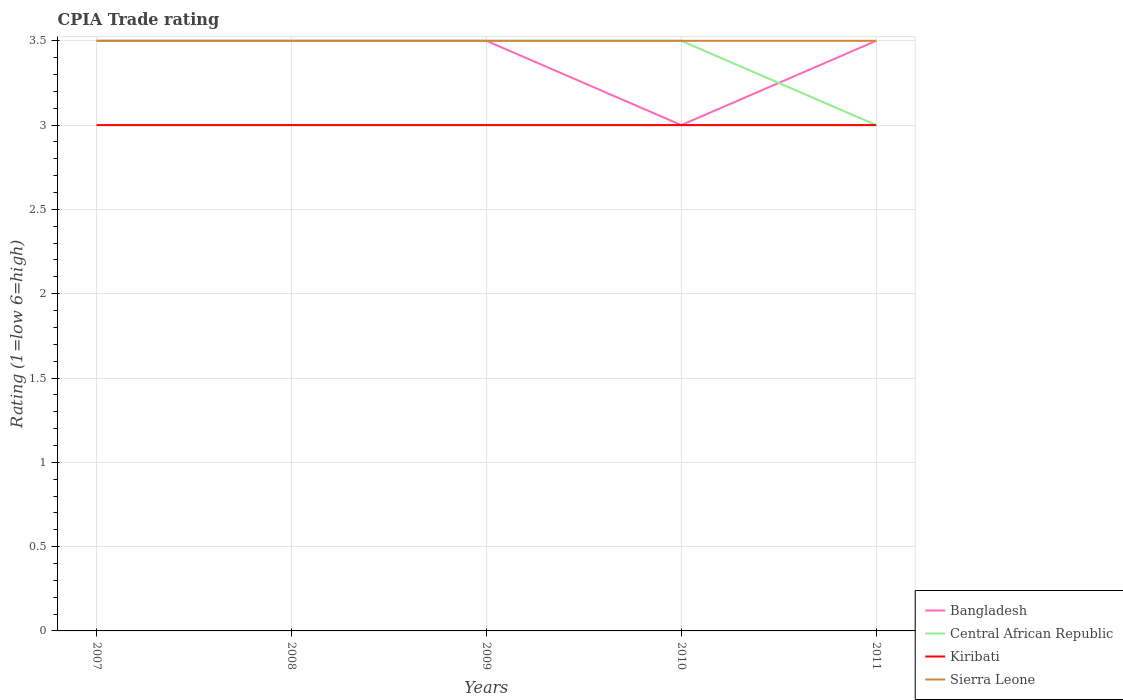How many different coloured lines are there?
Your response must be concise. 4. Across all years, what is the maximum CPIA rating in Bangladesh?
Ensure brevity in your answer.  3. In which year was the CPIA rating in Bangladesh maximum?
Ensure brevity in your answer.  2010. What is the difference between the highest and the lowest CPIA rating in Bangladesh?
Your response must be concise. 4. Is the CPIA rating in Bangladesh strictly greater than the CPIA rating in Sierra Leone over the years?
Ensure brevity in your answer.  No. Does the graph contain grids?
Give a very brief answer. Yes. What is the title of the graph?
Your response must be concise. CPIA Trade rating. What is the Rating (1=low 6=high) of Central African Republic in 2007?
Your answer should be compact. 3.5. What is the Rating (1=low 6=high) of Kiribati in 2007?
Provide a succinct answer. 3. What is the Rating (1=low 6=high) of Sierra Leone in 2007?
Offer a very short reply. 3.5. What is the Rating (1=low 6=high) in Bangladesh in 2008?
Offer a terse response. 3.5. What is the Rating (1=low 6=high) of Bangladesh in 2009?
Provide a succinct answer. 3.5. What is the Rating (1=low 6=high) in Central African Republic in 2009?
Your answer should be compact. 3.5. What is the Rating (1=low 6=high) in Central African Republic in 2010?
Your response must be concise. 3.5. What is the Rating (1=low 6=high) in Kiribati in 2010?
Give a very brief answer. 3. What is the Rating (1=low 6=high) in Sierra Leone in 2010?
Offer a very short reply. 3.5. What is the Rating (1=low 6=high) in Central African Republic in 2011?
Offer a terse response. 3. What is the Rating (1=low 6=high) in Kiribati in 2011?
Make the answer very short. 3. What is the Rating (1=low 6=high) of Sierra Leone in 2011?
Your response must be concise. 3.5. Across all years, what is the maximum Rating (1=low 6=high) in Kiribati?
Your response must be concise. 3. Across all years, what is the maximum Rating (1=low 6=high) in Sierra Leone?
Provide a succinct answer. 3.5. Across all years, what is the minimum Rating (1=low 6=high) in Bangladesh?
Make the answer very short. 3. Across all years, what is the minimum Rating (1=low 6=high) of Central African Republic?
Offer a terse response. 3. What is the total Rating (1=low 6=high) in Bangladesh in the graph?
Provide a succinct answer. 17. What is the total Rating (1=low 6=high) in Kiribati in the graph?
Your answer should be very brief. 15. What is the difference between the Rating (1=low 6=high) in Central African Republic in 2007 and that in 2008?
Provide a succinct answer. 0. What is the difference between the Rating (1=low 6=high) of Kiribati in 2007 and that in 2008?
Your answer should be compact. 0. What is the difference between the Rating (1=low 6=high) in Sierra Leone in 2007 and that in 2009?
Provide a short and direct response. 0. What is the difference between the Rating (1=low 6=high) in Central African Republic in 2007 and that in 2011?
Keep it short and to the point. 0.5. What is the difference between the Rating (1=low 6=high) in Sierra Leone in 2007 and that in 2011?
Your answer should be compact. 0. What is the difference between the Rating (1=low 6=high) in Central African Republic in 2008 and that in 2009?
Keep it short and to the point. 0. What is the difference between the Rating (1=low 6=high) of Kiribati in 2008 and that in 2010?
Keep it short and to the point. 0. What is the difference between the Rating (1=low 6=high) of Sierra Leone in 2008 and that in 2010?
Give a very brief answer. 0. What is the difference between the Rating (1=low 6=high) of Central African Republic in 2008 and that in 2011?
Make the answer very short. 0.5. What is the difference between the Rating (1=low 6=high) in Kiribati in 2009 and that in 2010?
Ensure brevity in your answer.  0. What is the difference between the Rating (1=low 6=high) in Central African Republic in 2009 and that in 2011?
Offer a very short reply. 0.5. What is the difference between the Rating (1=low 6=high) in Kiribati in 2009 and that in 2011?
Give a very brief answer. 0. What is the difference between the Rating (1=low 6=high) in Bangladesh in 2010 and that in 2011?
Offer a very short reply. -0.5. What is the difference between the Rating (1=low 6=high) of Sierra Leone in 2010 and that in 2011?
Offer a terse response. 0. What is the difference between the Rating (1=low 6=high) of Bangladesh in 2007 and the Rating (1=low 6=high) of Central African Republic in 2008?
Your response must be concise. 0. What is the difference between the Rating (1=low 6=high) of Bangladesh in 2007 and the Rating (1=low 6=high) of Sierra Leone in 2008?
Ensure brevity in your answer.  0. What is the difference between the Rating (1=low 6=high) of Central African Republic in 2007 and the Rating (1=low 6=high) of Sierra Leone in 2008?
Provide a succinct answer. 0. What is the difference between the Rating (1=low 6=high) of Kiribati in 2007 and the Rating (1=low 6=high) of Sierra Leone in 2008?
Offer a very short reply. -0.5. What is the difference between the Rating (1=low 6=high) of Bangladesh in 2007 and the Rating (1=low 6=high) of Central African Republic in 2009?
Make the answer very short. 0. What is the difference between the Rating (1=low 6=high) in Bangladesh in 2007 and the Rating (1=low 6=high) in Kiribati in 2009?
Ensure brevity in your answer.  0.5. What is the difference between the Rating (1=low 6=high) in Central African Republic in 2007 and the Rating (1=low 6=high) in Sierra Leone in 2009?
Ensure brevity in your answer.  0. What is the difference between the Rating (1=low 6=high) in Kiribati in 2007 and the Rating (1=low 6=high) in Sierra Leone in 2009?
Offer a terse response. -0.5. What is the difference between the Rating (1=low 6=high) in Bangladesh in 2007 and the Rating (1=low 6=high) in Central African Republic in 2010?
Offer a very short reply. 0. What is the difference between the Rating (1=low 6=high) of Bangladesh in 2007 and the Rating (1=low 6=high) of Kiribati in 2010?
Your answer should be very brief. 0.5. What is the difference between the Rating (1=low 6=high) in Bangladesh in 2007 and the Rating (1=low 6=high) in Sierra Leone in 2010?
Your answer should be very brief. 0. What is the difference between the Rating (1=low 6=high) of Central African Republic in 2007 and the Rating (1=low 6=high) of Kiribati in 2010?
Give a very brief answer. 0.5. What is the difference between the Rating (1=low 6=high) in Bangladesh in 2007 and the Rating (1=low 6=high) in Central African Republic in 2011?
Your response must be concise. 0.5. What is the difference between the Rating (1=low 6=high) of Central African Republic in 2008 and the Rating (1=low 6=high) of Kiribati in 2009?
Give a very brief answer. 0.5. What is the difference between the Rating (1=low 6=high) in Kiribati in 2008 and the Rating (1=low 6=high) in Sierra Leone in 2009?
Provide a short and direct response. -0.5. What is the difference between the Rating (1=low 6=high) in Bangladesh in 2008 and the Rating (1=low 6=high) in Kiribati in 2010?
Provide a short and direct response. 0.5. What is the difference between the Rating (1=low 6=high) in Bangladesh in 2008 and the Rating (1=low 6=high) in Sierra Leone in 2010?
Make the answer very short. 0. What is the difference between the Rating (1=low 6=high) of Central African Republic in 2008 and the Rating (1=low 6=high) of Sierra Leone in 2010?
Keep it short and to the point. 0. What is the difference between the Rating (1=low 6=high) of Bangladesh in 2008 and the Rating (1=low 6=high) of Central African Republic in 2011?
Your response must be concise. 0.5. What is the difference between the Rating (1=low 6=high) in Bangladesh in 2008 and the Rating (1=low 6=high) in Sierra Leone in 2011?
Offer a very short reply. 0. What is the difference between the Rating (1=low 6=high) of Central African Republic in 2008 and the Rating (1=low 6=high) of Kiribati in 2011?
Ensure brevity in your answer.  0.5. What is the difference between the Rating (1=low 6=high) in Central African Republic in 2008 and the Rating (1=low 6=high) in Sierra Leone in 2011?
Your answer should be very brief. 0. What is the difference between the Rating (1=low 6=high) in Kiribati in 2008 and the Rating (1=low 6=high) in Sierra Leone in 2011?
Your response must be concise. -0.5. What is the difference between the Rating (1=low 6=high) in Bangladesh in 2009 and the Rating (1=low 6=high) in Central African Republic in 2010?
Your answer should be compact. 0. What is the difference between the Rating (1=low 6=high) in Bangladesh in 2009 and the Rating (1=low 6=high) in Kiribati in 2010?
Keep it short and to the point. 0.5. What is the difference between the Rating (1=low 6=high) in Central African Republic in 2009 and the Rating (1=low 6=high) in Sierra Leone in 2010?
Your answer should be compact. 0. What is the difference between the Rating (1=low 6=high) of Kiribati in 2009 and the Rating (1=low 6=high) of Sierra Leone in 2010?
Ensure brevity in your answer.  -0.5. What is the difference between the Rating (1=low 6=high) in Bangladesh in 2009 and the Rating (1=low 6=high) in Central African Republic in 2011?
Provide a succinct answer. 0.5. What is the difference between the Rating (1=low 6=high) in Bangladesh in 2009 and the Rating (1=low 6=high) in Sierra Leone in 2011?
Offer a terse response. 0. What is the difference between the Rating (1=low 6=high) of Central African Republic in 2009 and the Rating (1=low 6=high) of Sierra Leone in 2011?
Your response must be concise. 0. What is the difference between the Rating (1=low 6=high) in Kiribati in 2009 and the Rating (1=low 6=high) in Sierra Leone in 2011?
Provide a short and direct response. -0.5. What is the difference between the Rating (1=low 6=high) in Bangladesh in 2010 and the Rating (1=low 6=high) in Sierra Leone in 2011?
Make the answer very short. -0.5. What is the difference between the Rating (1=low 6=high) of Central African Republic in 2010 and the Rating (1=low 6=high) of Kiribati in 2011?
Your answer should be compact. 0.5. What is the average Rating (1=low 6=high) in Sierra Leone per year?
Your answer should be very brief. 3.5. In the year 2007, what is the difference between the Rating (1=low 6=high) in Bangladesh and Rating (1=low 6=high) in Central African Republic?
Your answer should be compact. 0. In the year 2007, what is the difference between the Rating (1=low 6=high) in Bangladesh and Rating (1=low 6=high) in Kiribati?
Offer a terse response. 0.5. In the year 2007, what is the difference between the Rating (1=low 6=high) in Central African Republic and Rating (1=low 6=high) in Kiribati?
Make the answer very short. 0.5. In the year 2008, what is the difference between the Rating (1=low 6=high) of Central African Republic and Rating (1=low 6=high) of Kiribati?
Your answer should be very brief. 0.5. In the year 2009, what is the difference between the Rating (1=low 6=high) in Bangladesh and Rating (1=low 6=high) in Central African Republic?
Your answer should be compact. 0. In the year 2009, what is the difference between the Rating (1=low 6=high) of Bangladesh and Rating (1=low 6=high) of Kiribati?
Make the answer very short. 0.5. In the year 2009, what is the difference between the Rating (1=low 6=high) of Bangladesh and Rating (1=low 6=high) of Sierra Leone?
Your answer should be very brief. 0. In the year 2009, what is the difference between the Rating (1=low 6=high) in Central African Republic and Rating (1=low 6=high) in Kiribati?
Your answer should be compact. 0.5. In the year 2009, what is the difference between the Rating (1=low 6=high) of Central African Republic and Rating (1=low 6=high) of Sierra Leone?
Your response must be concise. 0. In the year 2009, what is the difference between the Rating (1=low 6=high) of Kiribati and Rating (1=low 6=high) of Sierra Leone?
Your answer should be very brief. -0.5. In the year 2010, what is the difference between the Rating (1=low 6=high) of Bangladesh and Rating (1=low 6=high) of Central African Republic?
Make the answer very short. -0.5. In the year 2010, what is the difference between the Rating (1=low 6=high) in Kiribati and Rating (1=low 6=high) in Sierra Leone?
Make the answer very short. -0.5. In the year 2011, what is the difference between the Rating (1=low 6=high) in Bangladesh and Rating (1=low 6=high) in Kiribati?
Make the answer very short. 0.5. In the year 2011, what is the difference between the Rating (1=low 6=high) of Kiribati and Rating (1=low 6=high) of Sierra Leone?
Keep it short and to the point. -0.5. What is the ratio of the Rating (1=low 6=high) of Central African Republic in 2007 to that in 2009?
Provide a succinct answer. 1. What is the ratio of the Rating (1=low 6=high) in Kiribati in 2007 to that in 2009?
Your answer should be very brief. 1. What is the ratio of the Rating (1=low 6=high) of Sierra Leone in 2007 to that in 2009?
Your answer should be very brief. 1. What is the ratio of the Rating (1=low 6=high) of Bangladesh in 2007 to that in 2010?
Keep it short and to the point. 1.17. What is the ratio of the Rating (1=low 6=high) in Central African Republic in 2007 to that in 2010?
Your response must be concise. 1. What is the ratio of the Rating (1=low 6=high) of Bangladesh in 2007 to that in 2011?
Give a very brief answer. 1. What is the ratio of the Rating (1=low 6=high) in Kiribati in 2007 to that in 2011?
Offer a very short reply. 1. What is the ratio of the Rating (1=low 6=high) of Kiribati in 2008 to that in 2009?
Provide a succinct answer. 1. What is the ratio of the Rating (1=low 6=high) of Bangladesh in 2008 to that in 2010?
Offer a terse response. 1.17. What is the ratio of the Rating (1=low 6=high) of Central African Republic in 2008 to that in 2010?
Your answer should be compact. 1. What is the ratio of the Rating (1=low 6=high) in Kiribati in 2008 to that in 2010?
Keep it short and to the point. 1. What is the ratio of the Rating (1=low 6=high) in Sierra Leone in 2008 to that in 2010?
Offer a very short reply. 1. What is the ratio of the Rating (1=low 6=high) of Central African Republic in 2008 to that in 2011?
Give a very brief answer. 1.17. What is the ratio of the Rating (1=low 6=high) in Sierra Leone in 2008 to that in 2011?
Keep it short and to the point. 1. What is the ratio of the Rating (1=low 6=high) in Kiribati in 2009 to that in 2010?
Your response must be concise. 1. What is the ratio of the Rating (1=low 6=high) of Central African Republic in 2009 to that in 2011?
Provide a short and direct response. 1.17. What is the ratio of the Rating (1=low 6=high) in Kiribati in 2009 to that in 2011?
Make the answer very short. 1. What is the ratio of the Rating (1=low 6=high) of Sierra Leone in 2009 to that in 2011?
Ensure brevity in your answer.  1. What is the ratio of the Rating (1=low 6=high) in Kiribati in 2010 to that in 2011?
Give a very brief answer. 1. What is the ratio of the Rating (1=low 6=high) of Sierra Leone in 2010 to that in 2011?
Offer a terse response. 1. What is the difference between the highest and the second highest Rating (1=low 6=high) of Bangladesh?
Offer a very short reply. 0. What is the difference between the highest and the second highest Rating (1=low 6=high) of Central African Republic?
Keep it short and to the point. 0. What is the difference between the highest and the second highest Rating (1=low 6=high) of Kiribati?
Give a very brief answer. 0. What is the difference between the highest and the second highest Rating (1=low 6=high) of Sierra Leone?
Give a very brief answer. 0. What is the difference between the highest and the lowest Rating (1=low 6=high) of Central African Republic?
Keep it short and to the point. 0.5. What is the difference between the highest and the lowest Rating (1=low 6=high) of Kiribati?
Provide a short and direct response. 0. What is the difference between the highest and the lowest Rating (1=low 6=high) in Sierra Leone?
Provide a succinct answer. 0. 